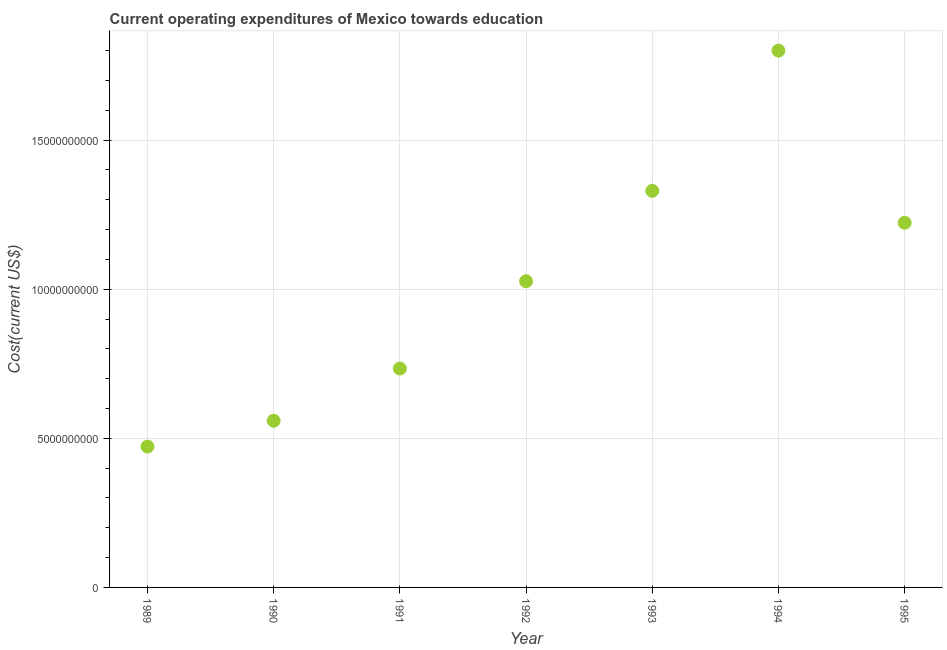What is the education expenditure in 1995?
Provide a succinct answer. 1.22e+1. Across all years, what is the maximum education expenditure?
Your answer should be compact. 1.80e+1. Across all years, what is the minimum education expenditure?
Your answer should be very brief. 4.72e+09. What is the sum of the education expenditure?
Provide a short and direct response. 7.14e+1. What is the difference between the education expenditure in 1989 and 1993?
Give a very brief answer. -8.58e+09. What is the average education expenditure per year?
Your answer should be very brief. 1.02e+1. What is the median education expenditure?
Offer a very short reply. 1.03e+1. In how many years, is the education expenditure greater than 2000000000 US$?
Your answer should be compact. 7. What is the ratio of the education expenditure in 1990 to that in 1992?
Your answer should be compact. 0.54. What is the difference between the highest and the second highest education expenditure?
Provide a succinct answer. 4.70e+09. Is the sum of the education expenditure in 1992 and 1993 greater than the maximum education expenditure across all years?
Keep it short and to the point. Yes. What is the difference between the highest and the lowest education expenditure?
Ensure brevity in your answer.  1.33e+1. In how many years, is the education expenditure greater than the average education expenditure taken over all years?
Provide a succinct answer. 4. How many dotlines are there?
Make the answer very short. 1. What is the difference between two consecutive major ticks on the Y-axis?
Your answer should be very brief. 5.00e+09. Are the values on the major ticks of Y-axis written in scientific E-notation?
Your answer should be compact. No. Does the graph contain grids?
Your answer should be very brief. Yes. What is the title of the graph?
Your answer should be compact. Current operating expenditures of Mexico towards education. What is the label or title of the X-axis?
Offer a very short reply. Year. What is the label or title of the Y-axis?
Your response must be concise. Cost(current US$). What is the Cost(current US$) in 1989?
Offer a very short reply. 4.72e+09. What is the Cost(current US$) in 1990?
Provide a succinct answer. 5.59e+09. What is the Cost(current US$) in 1991?
Ensure brevity in your answer.  7.34e+09. What is the Cost(current US$) in 1992?
Keep it short and to the point. 1.03e+1. What is the Cost(current US$) in 1993?
Offer a terse response. 1.33e+1. What is the Cost(current US$) in 1994?
Your answer should be very brief. 1.80e+1. What is the Cost(current US$) in 1995?
Keep it short and to the point. 1.22e+1. What is the difference between the Cost(current US$) in 1989 and 1990?
Give a very brief answer. -8.67e+08. What is the difference between the Cost(current US$) in 1989 and 1991?
Ensure brevity in your answer.  -2.62e+09. What is the difference between the Cost(current US$) in 1989 and 1992?
Your response must be concise. -5.54e+09. What is the difference between the Cost(current US$) in 1989 and 1993?
Give a very brief answer. -8.58e+09. What is the difference between the Cost(current US$) in 1989 and 1994?
Offer a terse response. -1.33e+1. What is the difference between the Cost(current US$) in 1989 and 1995?
Provide a short and direct response. -7.51e+09. What is the difference between the Cost(current US$) in 1990 and 1991?
Make the answer very short. -1.75e+09. What is the difference between the Cost(current US$) in 1990 and 1992?
Ensure brevity in your answer.  -4.68e+09. What is the difference between the Cost(current US$) in 1990 and 1993?
Provide a short and direct response. -7.71e+09. What is the difference between the Cost(current US$) in 1990 and 1994?
Provide a succinct answer. -1.24e+1. What is the difference between the Cost(current US$) in 1990 and 1995?
Make the answer very short. -6.64e+09. What is the difference between the Cost(current US$) in 1991 and 1992?
Your answer should be very brief. -2.93e+09. What is the difference between the Cost(current US$) in 1991 and 1993?
Make the answer very short. -5.96e+09. What is the difference between the Cost(current US$) in 1991 and 1994?
Make the answer very short. -1.07e+1. What is the difference between the Cost(current US$) in 1991 and 1995?
Make the answer very short. -4.89e+09. What is the difference between the Cost(current US$) in 1992 and 1993?
Offer a terse response. -3.03e+09. What is the difference between the Cost(current US$) in 1992 and 1994?
Provide a short and direct response. -7.73e+09. What is the difference between the Cost(current US$) in 1992 and 1995?
Your answer should be compact. -1.96e+09. What is the difference between the Cost(current US$) in 1993 and 1994?
Ensure brevity in your answer.  -4.70e+09. What is the difference between the Cost(current US$) in 1993 and 1995?
Your answer should be compact. 1.07e+09. What is the difference between the Cost(current US$) in 1994 and 1995?
Ensure brevity in your answer.  5.77e+09. What is the ratio of the Cost(current US$) in 1989 to that in 1990?
Offer a very short reply. 0.84. What is the ratio of the Cost(current US$) in 1989 to that in 1991?
Make the answer very short. 0.64. What is the ratio of the Cost(current US$) in 1989 to that in 1992?
Ensure brevity in your answer.  0.46. What is the ratio of the Cost(current US$) in 1989 to that in 1993?
Your answer should be very brief. 0.35. What is the ratio of the Cost(current US$) in 1989 to that in 1994?
Your answer should be compact. 0.26. What is the ratio of the Cost(current US$) in 1989 to that in 1995?
Your response must be concise. 0.39. What is the ratio of the Cost(current US$) in 1990 to that in 1991?
Provide a succinct answer. 0.76. What is the ratio of the Cost(current US$) in 1990 to that in 1992?
Ensure brevity in your answer.  0.54. What is the ratio of the Cost(current US$) in 1990 to that in 1993?
Offer a terse response. 0.42. What is the ratio of the Cost(current US$) in 1990 to that in 1994?
Make the answer very short. 0.31. What is the ratio of the Cost(current US$) in 1990 to that in 1995?
Offer a terse response. 0.46. What is the ratio of the Cost(current US$) in 1991 to that in 1992?
Ensure brevity in your answer.  0.71. What is the ratio of the Cost(current US$) in 1991 to that in 1993?
Your answer should be very brief. 0.55. What is the ratio of the Cost(current US$) in 1991 to that in 1994?
Make the answer very short. 0.41. What is the ratio of the Cost(current US$) in 1992 to that in 1993?
Keep it short and to the point. 0.77. What is the ratio of the Cost(current US$) in 1992 to that in 1994?
Offer a terse response. 0.57. What is the ratio of the Cost(current US$) in 1992 to that in 1995?
Make the answer very short. 0.84. What is the ratio of the Cost(current US$) in 1993 to that in 1994?
Your answer should be very brief. 0.74. What is the ratio of the Cost(current US$) in 1993 to that in 1995?
Make the answer very short. 1.09. What is the ratio of the Cost(current US$) in 1994 to that in 1995?
Give a very brief answer. 1.47. 